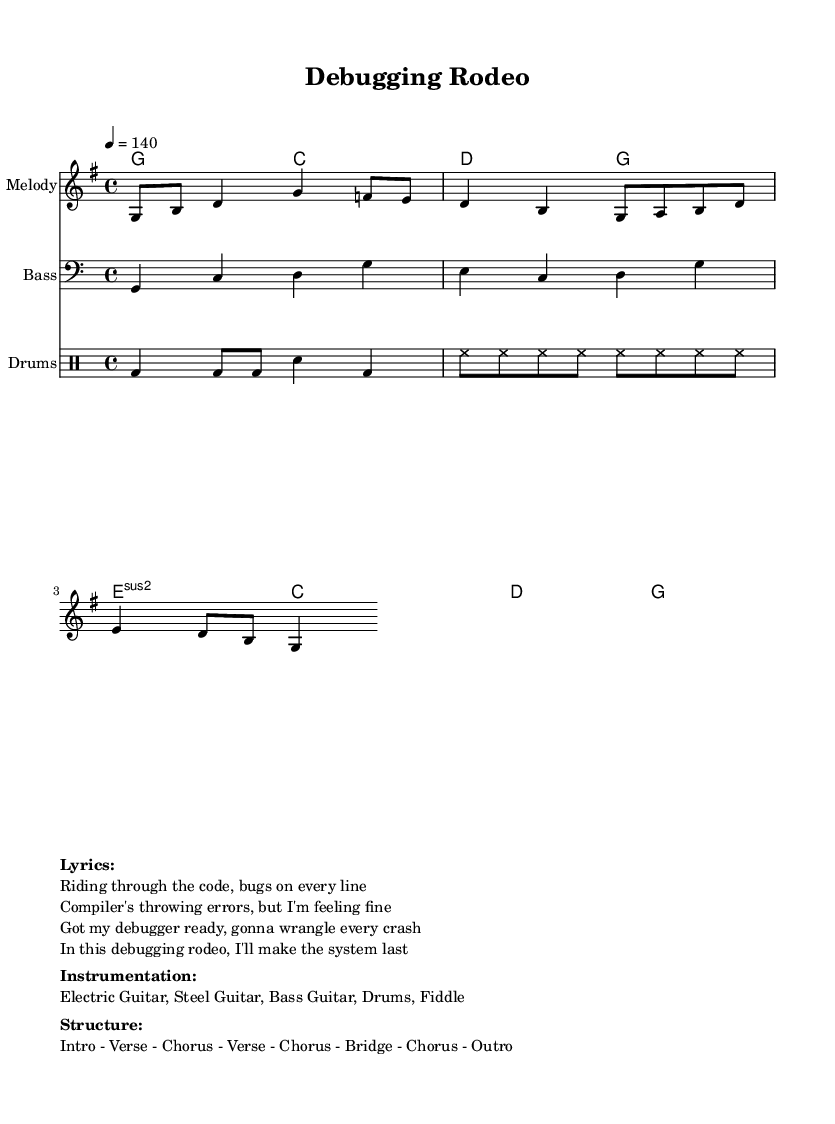What is the key signature of this music? The key signature is G major, which has one sharp (F#). This can be determined from the global settings in the code, specifically the line `\key g \major`.
Answer: G major What is the time signature of this music? The time signature is 4/4, as indicated in the global settings with the line `\time 4/4`. This means there are four beats in a measure and the quarter note receives one beat.
Answer: 4/4 What is the tempo marking for this piece? The tempo marking is 140 beats per minute, specified in the global section with `\tempo 4 = 140`. This indicates how fast the piece should be played.
Answer: 140 How many sections are there in the song structure? The song structure includes seven distinct sections: Intro, Verse, Chorus, Verse, Chorus, Bridge, and Chorus, as outlined in the "Structure" markup.
Answer: 7 What instruments are used in this piece? The instrumentation listed includes Electric Guitar, Steel Guitar, Bass Guitar, Drums, and Fiddle, which is provided in the "Instrumentation" markup. These instruments are typical for high-energy country rock.
Answer: Electric Guitar, Steel Guitar, Bass Guitar, Drums, Fiddle What type of challenges does the song refer to? The song refers to "technical challenges and system crashes," as indicated by the lyrics which mention debugging, compilers, and errors, reflecting the theme of overcoming difficulties in software engineering.
Answer: Technical challenges and system crashes What is the main theme of the lyrics? The main theme of the lyrics is about overcoming obstacles in programming and debugging, as evidenced by phrases like "Got my debugger ready," highlighting perseverance in the face of errors.
Answer: Overcoming programming obstacles 